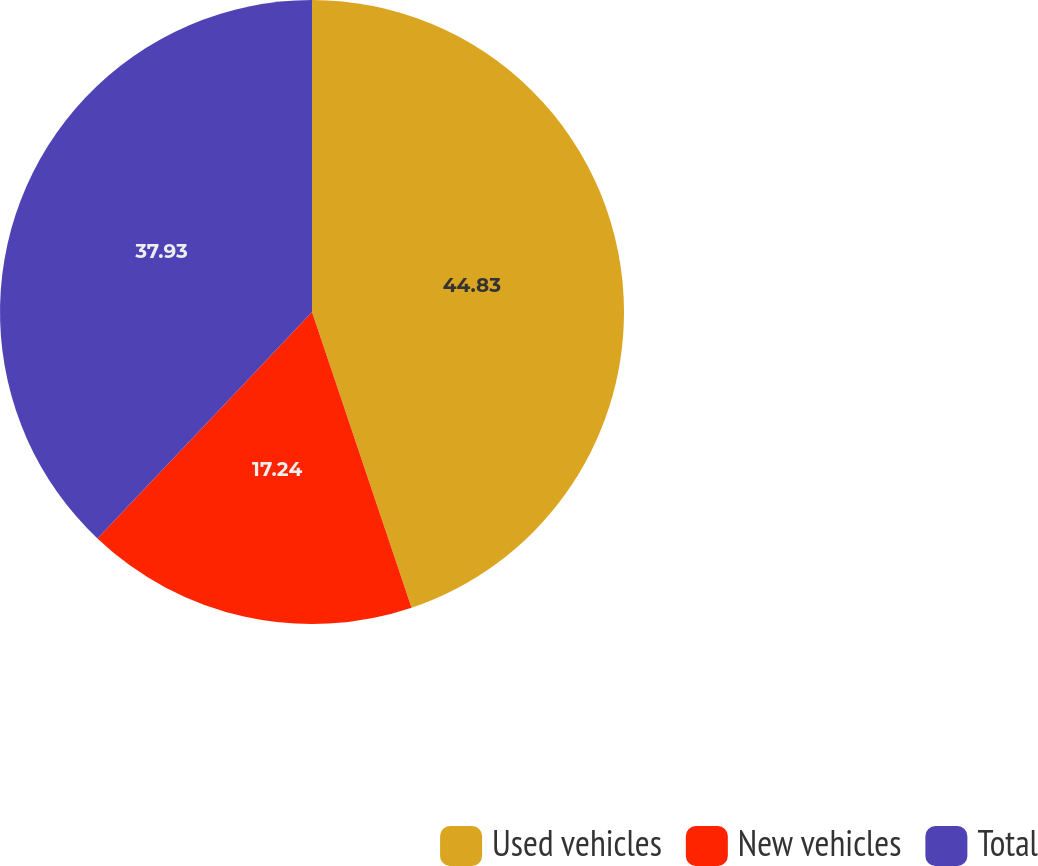Convert chart. <chart><loc_0><loc_0><loc_500><loc_500><pie_chart><fcel>Used vehicles<fcel>New vehicles<fcel>Total<nl><fcel>44.83%<fcel>17.24%<fcel>37.93%<nl></chart> 